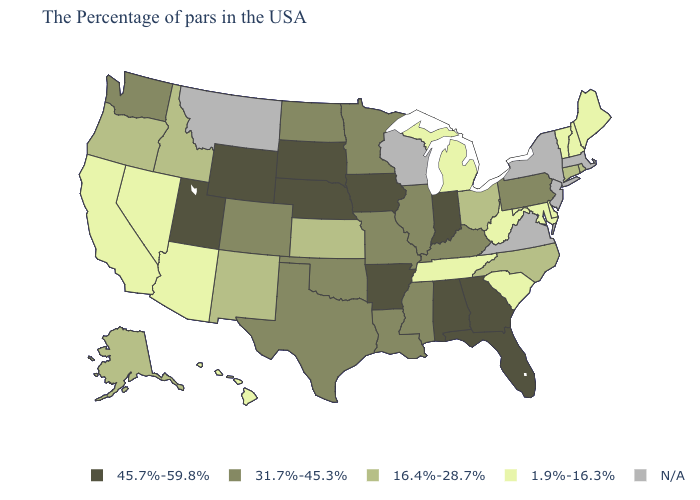What is the highest value in the USA?
Write a very short answer. 45.7%-59.8%. What is the lowest value in the MidWest?
Be succinct. 1.9%-16.3%. What is the highest value in states that border New Jersey?
Quick response, please. 31.7%-45.3%. Name the states that have a value in the range 31.7%-45.3%?
Concise answer only. Pennsylvania, Kentucky, Illinois, Mississippi, Louisiana, Missouri, Minnesota, Oklahoma, Texas, North Dakota, Colorado, Washington. Does the map have missing data?
Keep it brief. Yes. Does Maryland have the lowest value in the USA?
Write a very short answer. Yes. What is the value of Florida?
Answer briefly. 45.7%-59.8%. Name the states that have a value in the range 1.9%-16.3%?
Short answer required. Maine, New Hampshire, Vermont, Delaware, Maryland, South Carolina, West Virginia, Michigan, Tennessee, Arizona, Nevada, California, Hawaii. What is the value of Delaware?
Concise answer only. 1.9%-16.3%. Name the states that have a value in the range N/A?
Keep it brief. Massachusetts, New York, New Jersey, Virginia, Wisconsin, Montana. What is the lowest value in the USA?
Keep it brief. 1.9%-16.3%. What is the highest value in the USA?
Give a very brief answer. 45.7%-59.8%. What is the lowest value in the USA?
Short answer required. 1.9%-16.3%. Does Nebraska have the highest value in the MidWest?
Be succinct. Yes. Name the states that have a value in the range 31.7%-45.3%?
Write a very short answer. Pennsylvania, Kentucky, Illinois, Mississippi, Louisiana, Missouri, Minnesota, Oklahoma, Texas, North Dakota, Colorado, Washington. 